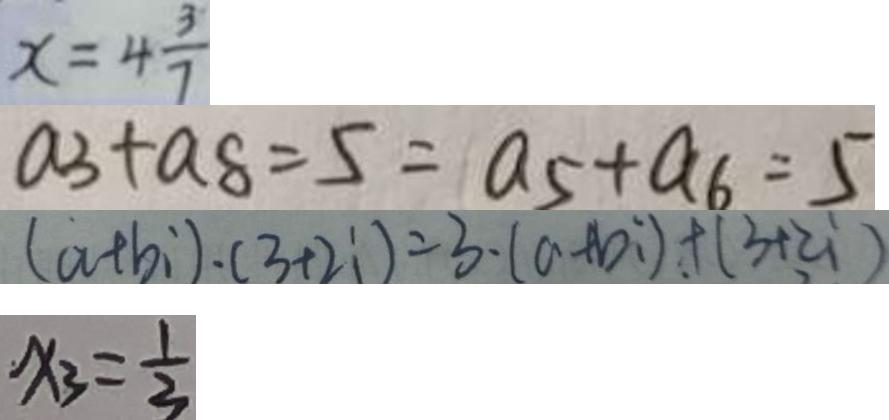<formula> <loc_0><loc_0><loc_500><loc_500>x = 4 \frac { 3 } { 7 } 
 a _ { 3 } + a _ { 8 } = 5 = a _ { 5 } + a _ { 6 } = 5 
 ( a + b i ) \cdot ( 3 + 2 i ) = 3 \cdot ( a + b i ) + ( 3 + z i ) 
 x _ { 3 } = \frac { 1 } { 3 }</formula> 